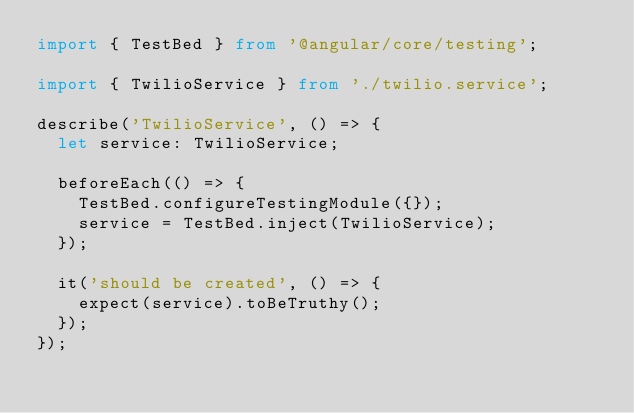Convert code to text. <code><loc_0><loc_0><loc_500><loc_500><_TypeScript_>import { TestBed } from '@angular/core/testing';

import { TwilioService } from './twilio.service';

describe('TwilioService', () => {
  let service: TwilioService;

  beforeEach(() => {
    TestBed.configureTestingModule({});
    service = TestBed.inject(TwilioService);
  });

  it('should be created', () => {
    expect(service).toBeTruthy();
  });
});
</code> 